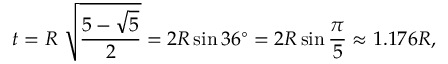Convert formula to latex. <formula><loc_0><loc_0><loc_500><loc_500>t = R \ { \sqrt { \frac { 5 - { \sqrt { 5 } } } { 2 } } } = 2 R \sin 3 6 ^ { \circ } = 2 R \sin { \frac { \pi } { 5 } } \approx 1 . 1 7 6 R ,</formula> 